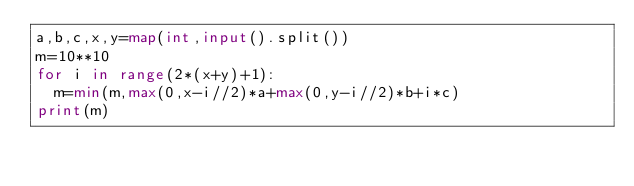<code> <loc_0><loc_0><loc_500><loc_500><_Python_>a,b,c,x,y=map(int,input().split())
m=10**10
for i in range(2*(x+y)+1):
  m=min(m,max(0,x-i//2)*a+max(0,y-i//2)*b+i*c)
print(m)
  </code> 